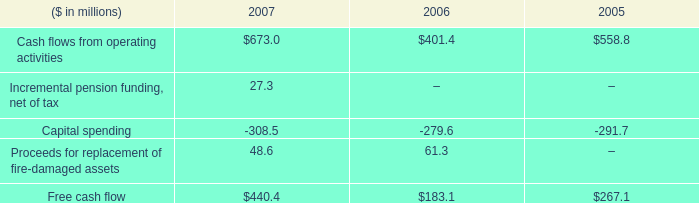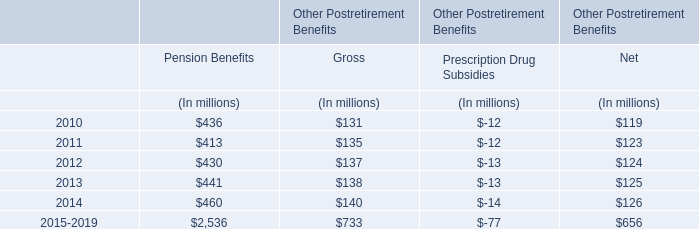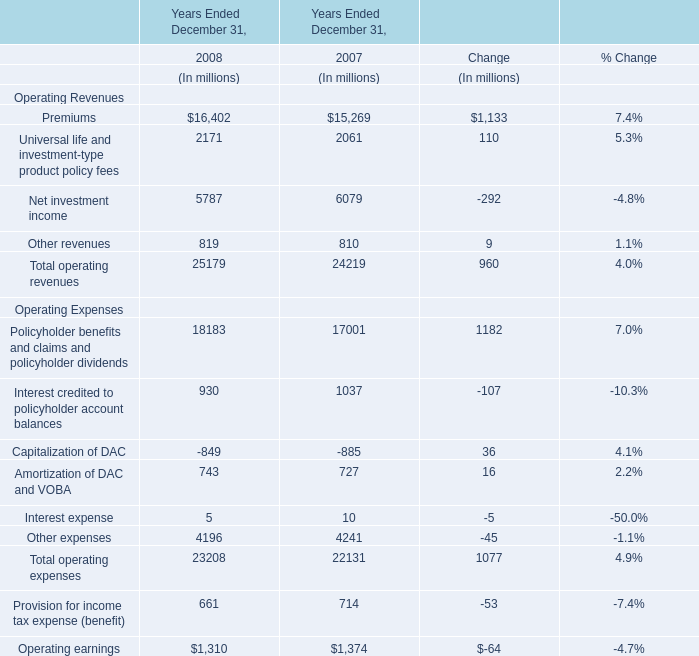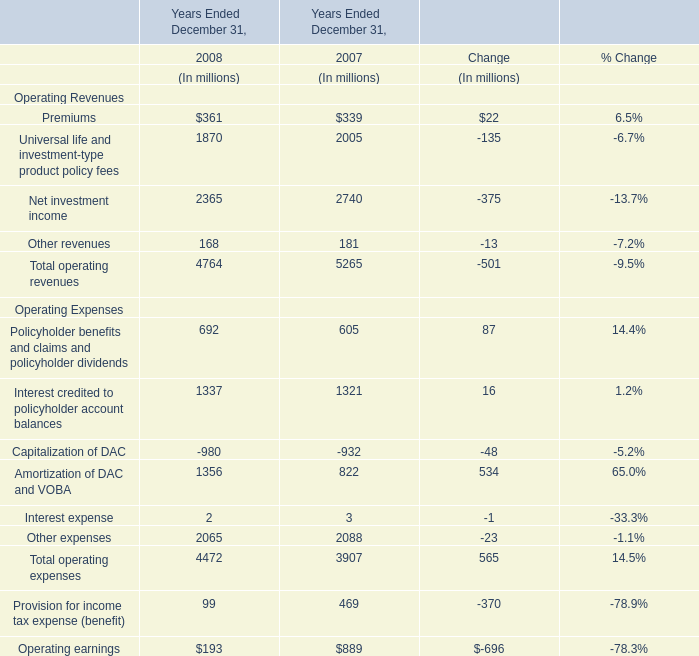What is the sum of Total operating revenues in 2008? (in million) 
Answer: 25179. 